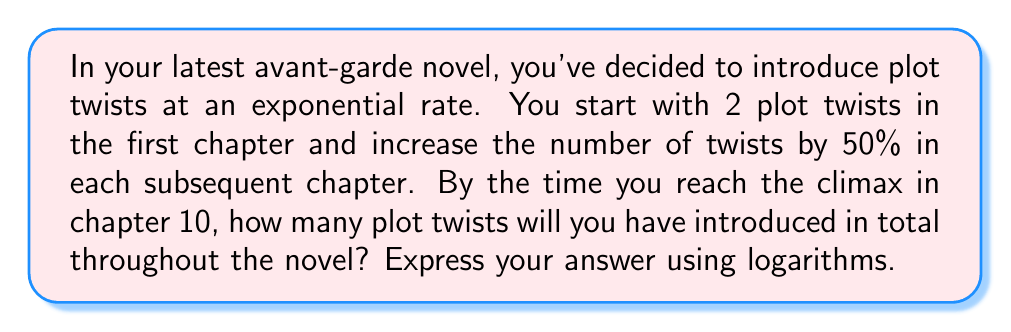Teach me how to tackle this problem. Let's approach this step-by-step:

1) First, we need to find the number of plot twists in each chapter:
   Chapter 1: 2
   Chapter 2: $2 \times 1.5 = 3$
   Chapter 3: $3 \times 1.5 = 4.5$
   And so on...

2) This forms a geometric sequence with first term $a = 2$ and common ratio $r = 1.5$

3) The number of plot twists in chapter $n$ is given by:
   $a_n = 2 \times 1.5^{n-1}$

4) We need to find the sum of this geometric series from chapters 1 to 10:
   $S_{10} = \frac{a(1-r^n)}{1-r}$ where $n = 10$

5) Substituting our values:
   $S_{10} = \frac{2(1-1.5^{10})}{1-1.5} = \frac{2(1-1.5^{10})}{-0.5}$

6) Simplify:
   $S_{10} = -4(1-1.5^{10})$

7) To express this using logarithms, we can rewrite $1.5^{10}$ as $e^{10\ln(1.5)}$:
   $S_{10} = -4(1-e^{10\ln(1.5)})$

8) Therefore, the total number of plot twists is:
   $4(e^{10\ln(1.5)} - 1)$

This expression uses the natural logarithm and exponential function, which are inverse operations of each other, reflecting the rebellious nature of your storytelling approach.
Answer: $4(e^{10\ln(1.5)} - 1)$ plot twists 